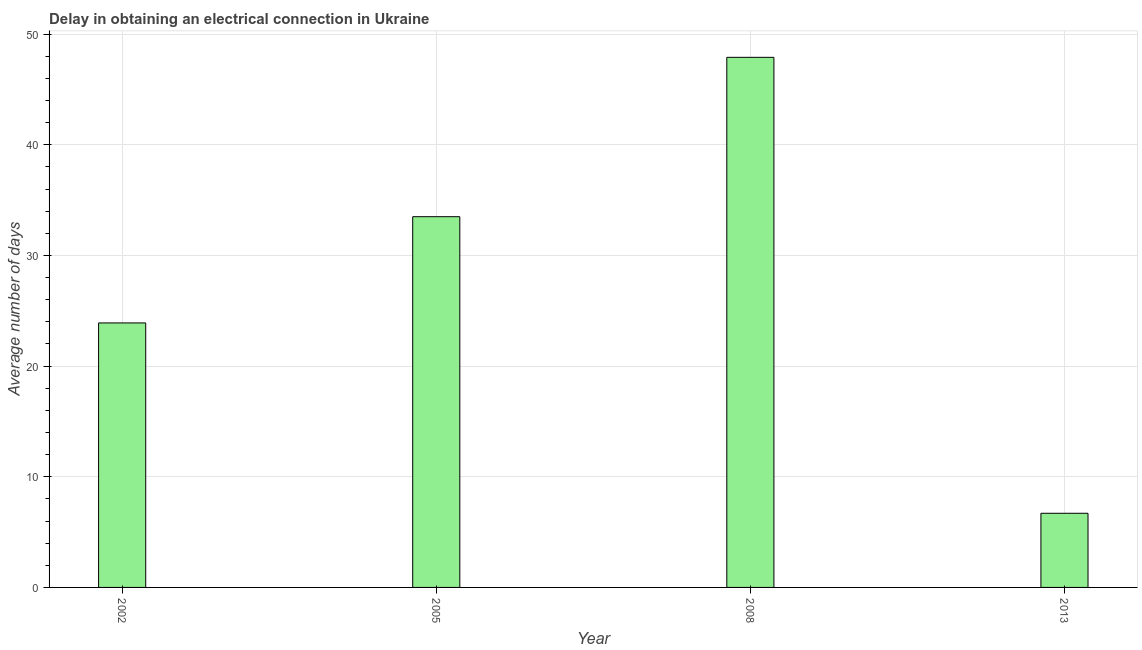Does the graph contain any zero values?
Your answer should be compact. No. What is the title of the graph?
Make the answer very short. Delay in obtaining an electrical connection in Ukraine. What is the label or title of the X-axis?
Offer a very short reply. Year. What is the label or title of the Y-axis?
Your answer should be very brief. Average number of days. What is the dalay in electrical connection in 2013?
Give a very brief answer. 6.7. Across all years, what is the maximum dalay in electrical connection?
Provide a short and direct response. 47.9. In which year was the dalay in electrical connection maximum?
Offer a terse response. 2008. What is the sum of the dalay in electrical connection?
Provide a short and direct response. 112. What is the average dalay in electrical connection per year?
Offer a very short reply. 28. What is the median dalay in electrical connection?
Offer a very short reply. 28.7. In how many years, is the dalay in electrical connection greater than 8 days?
Keep it short and to the point. 3. Do a majority of the years between 2008 and 2013 (inclusive) have dalay in electrical connection greater than 8 days?
Provide a short and direct response. No. What is the ratio of the dalay in electrical connection in 2002 to that in 2008?
Provide a short and direct response. 0.5. Is the dalay in electrical connection in 2005 less than that in 2013?
Provide a short and direct response. No. Is the difference between the dalay in electrical connection in 2002 and 2008 greater than the difference between any two years?
Offer a terse response. No. Is the sum of the dalay in electrical connection in 2005 and 2013 greater than the maximum dalay in electrical connection across all years?
Your answer should be very brief. No. What is the difference between the highest and the lowest dalay in electrical connection?
Offer a terse response. 41.2. In how many years, is the dalay in electrical connection greater than the average dalay in electrical connection taken over all years?
Ensure brevity in your answer.  2. What is the Average number of days of 2002?
Offer a terse response. 23.9. What is the Average number of days of 2005?
Give a very brief answer. 33.5. What is the Average number of days of 2008?
Your response must be concise. 47.9. What is the Average number of days in 2013?
Offer a terse response. 6.7. What is the difference between the Average number of days in 2002 and 2005?
Provide a short and direct response. -9.6. What is the difference between the Average number of days in 2002 and 2008?
Give a very brief answer. -24. What is the difference between the Average number of days in 2002 and 2013?
Keep it short and to the point. 17.2. What is the difference between the Average number of days in 2005 and 2008?
Keep it short and to the point. -14.4. What is the difference between the Average number of days in 2005 and 2013?
Your answer should be very brief. 26.8. What is the difference between the Average number of days in 2008 and 2013?
Provide a short and direct response. 41.2. What is the ratio of the Average number of days in 2002 to that in 2005?
Make the answer very short. 0.71. What is the ratio of the Average number of days in 2002 to that in 2008?
Provide a succinct answer. 0.5. What is the ratio of the Average number of days in 2002 to that in 2013?
Provide a short and direct response. 3.57. What is the ratio of the Average number of days in 2005 to that in 2008?
Make the answer very short. 0.7. What is the ratio of the Average number of days in 2005 to that in 2013?
Offer a very short reply. 5. What is the ratio of the Average number of days in 2008 to that in 2013?
Provide a succinct answer. 7.15. 